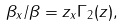<formula> <loc_0><loc_0><loc_500><loc_500>\beta _ { x } / \beta = z _ { x } \Gamma _ { 2 } ( z ) ,</formula> 